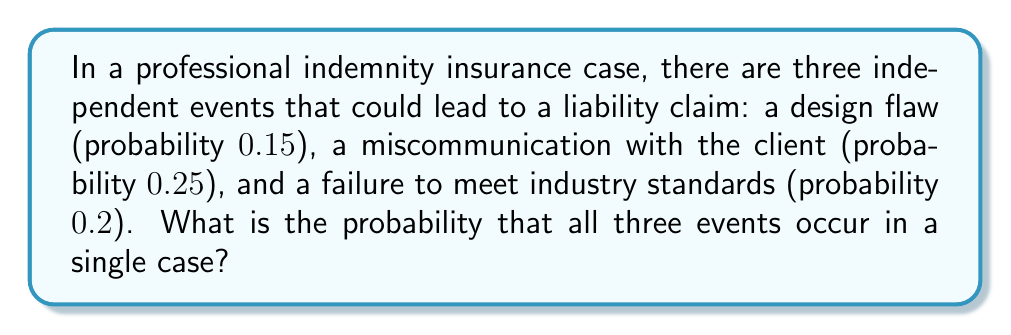Could you help me with this problem? To solve this problem, we need to use the multiplication rule for independent events. Since the events are independent, we multiply their individual probabilities:

1) Let's define our events:
   A: Design flaw (P(A) = 0.15)
   B: Miscommunication with client (P(B) = 0.25)
   C: Failure to meet industry standards (P(C) = 0.2)

2) We want to find P(A and B and C)

3) For independent events: P(A and B and C) = P(A) × P(B) × P(C)

4) Substituting the given probabilities:
   P(A and B and C) = 0.15 × 0.25 × 0.2

5) Calculating:
   P(A and B and C) = 0.15 × 0.25 × 0.2 = 0.0075

6) Therefore, the probability of all three events occurring in a single case is 0.0075 or 0.75%
Answer: $0.0075$ 